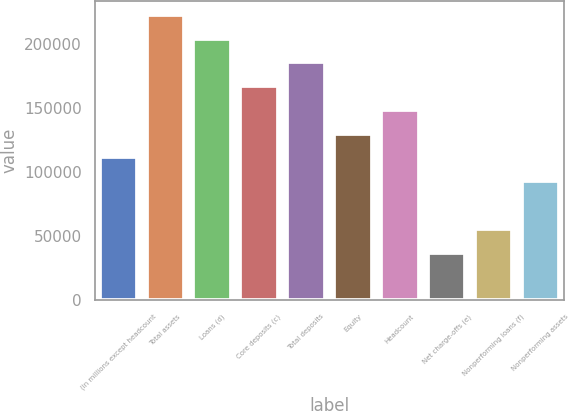<chart> <loc_0><loc_0><loc_500><loc_500><bar_chart><fcel>(in millions except headcount<fcel>Total assets<fcel>Loans (d)<fcel>Core deposits (c)<fcel>Total deposits<fcel>Equity<fcel>Headcount<fcel>Net charge-offs (e)<fcel>Nonperforming loans (f)<fcel>Nonperforming assets<nl><fcel>111557<fcel>223113<fcel>204521<fcel>167335<fcel>185928<fcel>130150<fcel>148743<fcel>37186.1<fcel>55778.9<fcel>92964.3<nl></chart> 